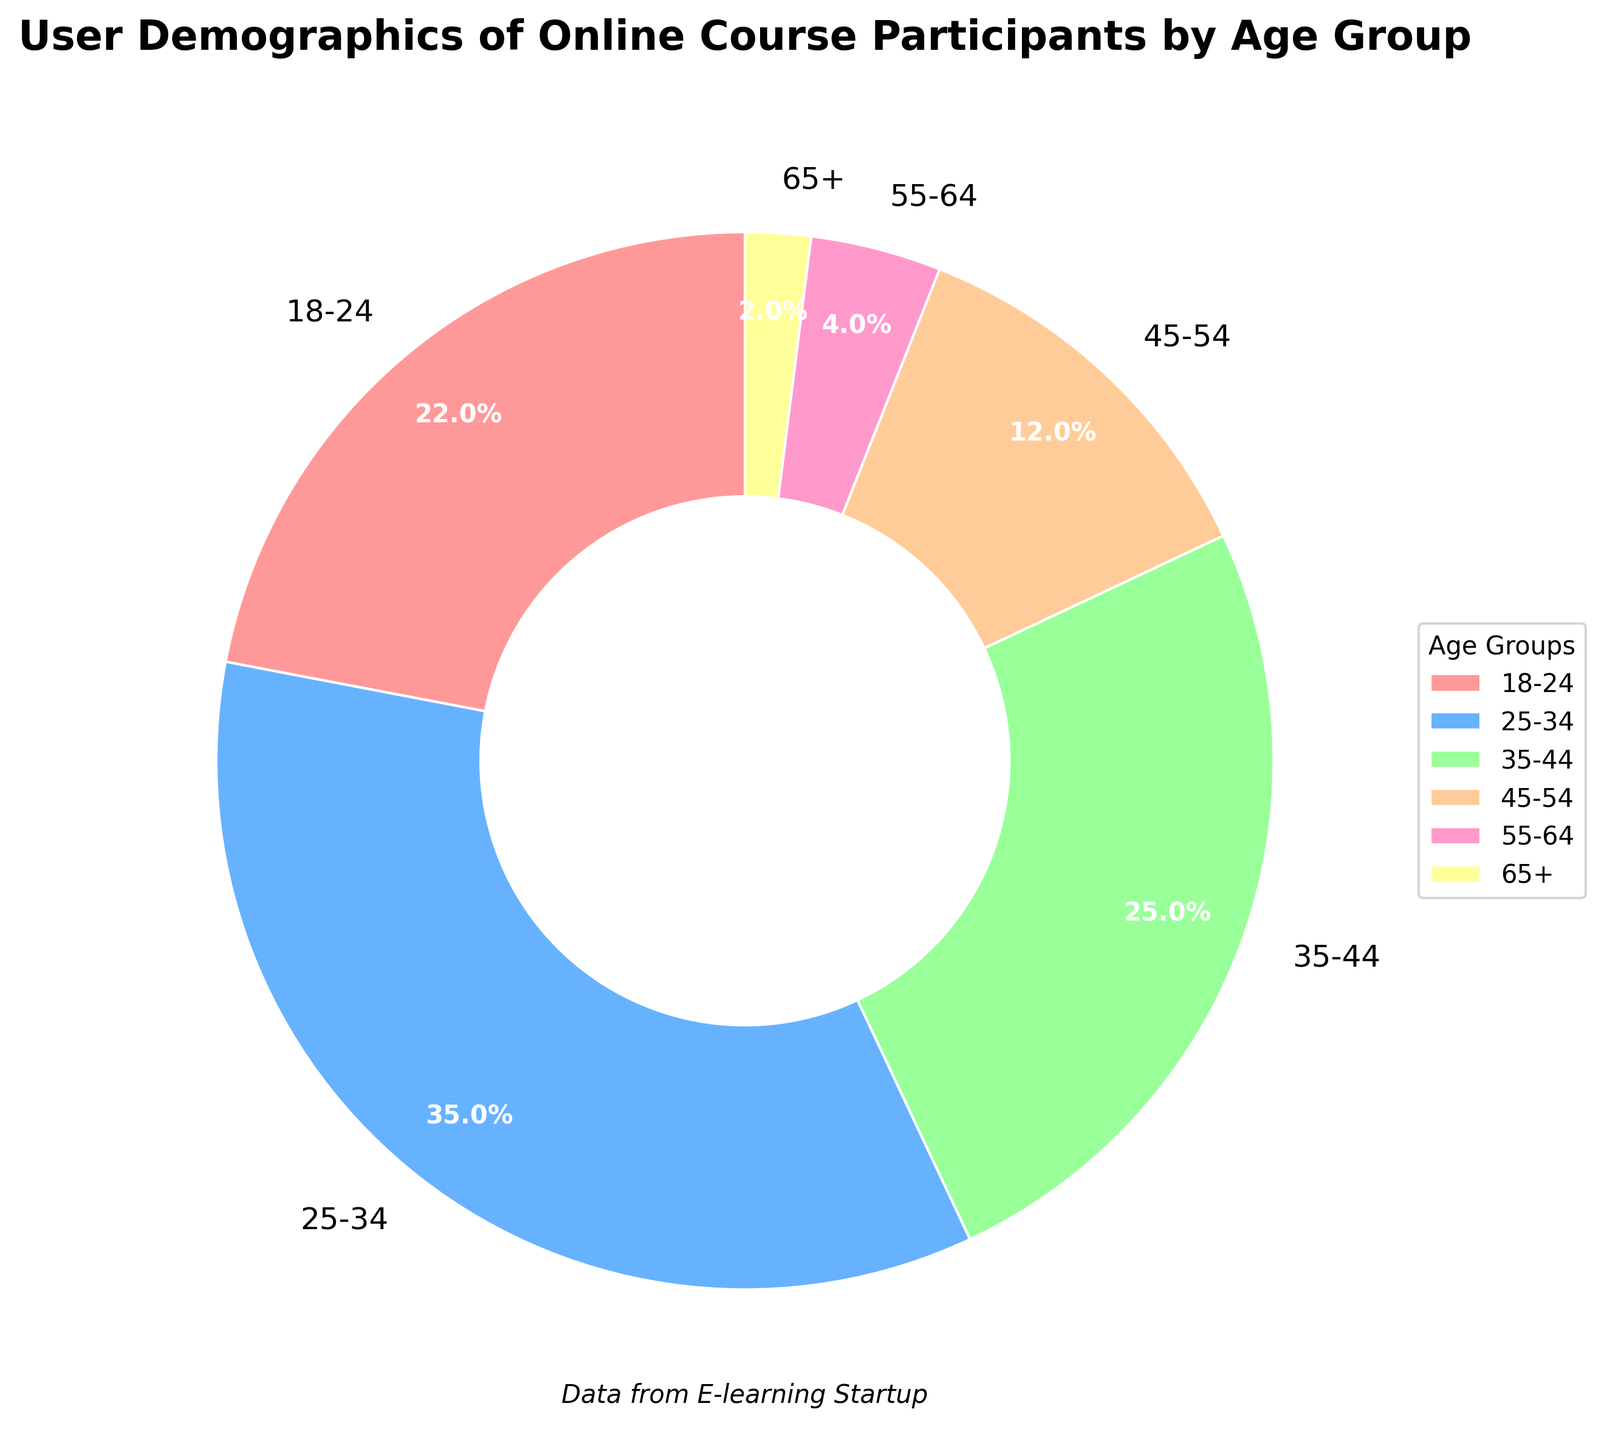What is the largest age group among online course participants? The largest age group can be identified by looking at the age group with the largest percentage. The age group '25-34' has the highest percentage at 35%.
Answer: 25-34 What is the total percentage of participants under the age of 35? Sum the percentages of the age groups '18-24' and '25-34'. The percentages are 22% and 35%, respectively. The total is 22% + 35% = 57%.
Answer: 57% How does the percentage of participants aged 45-54 compare to those aged 35-44? Compare the percentages of the age groups '45-54' and '35-44'. The percentages are 12% and 25%, respectively. The 35-44 age group has a higher percentage.
Answer: 35-44 What visual attributes distinguish the '25-34' age group's slice from others in the pie chart? The '25-34' age group's slice can be identified by its size and color. It is one of the largest slices and is colored blue.
Answer: Size and blue color How much more percentage of participants are there in the '35-44' age group compared to the '55-64' age group? Subtract the percentage of the '55-64' age group from the '35-44' age group. The percentages are 25% and 4%, respectively. So, 25% - 4% = 21%.
Answer: 21% What is the combined percentage of the three oldest age groups ('45-54', '55-64', and '65+')? Sum the percentages of the age groups '45-54', '55-64', and '65+'. The percentages are 12%, 4%, and 2%, respectively. The total is 12% + 4% + 2% = 18%.
Answer: 18% What is the color of the slice representing the '55-64' age group, and what is its percentage? The '55-64' age group's slice is colored pink and represents 4% of the total.
Answer: Pink, 4% Is the percentage of participants aged 18-24 less than twice the percentage of those aged 45-54? Compare if twice the percentage of the '45-54' age group (2 * 12% = 24%) is more than the '18-24' age group (22%). Yes, 22% is less than 24%.
Answer: Yes Which age group represents the smallest proportion of online course participants, and what percentage do they constitute? The '65+' age group has the smallest proportion of participants, constituting 2% of the total.
Answer: 65+, 2% 